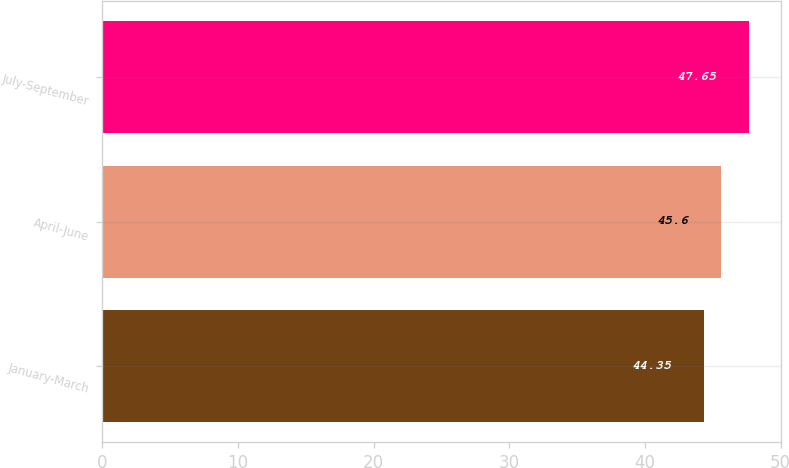Convert chart to OTSL. <chart><loc_0><loc_0><loc_500><loc_500><bar_chart><fcel>January-March<fcel>April-June<fcel>July-September<nl><fcel>44.35<fcel>45.6<fcel>47.65<nl></chart> 